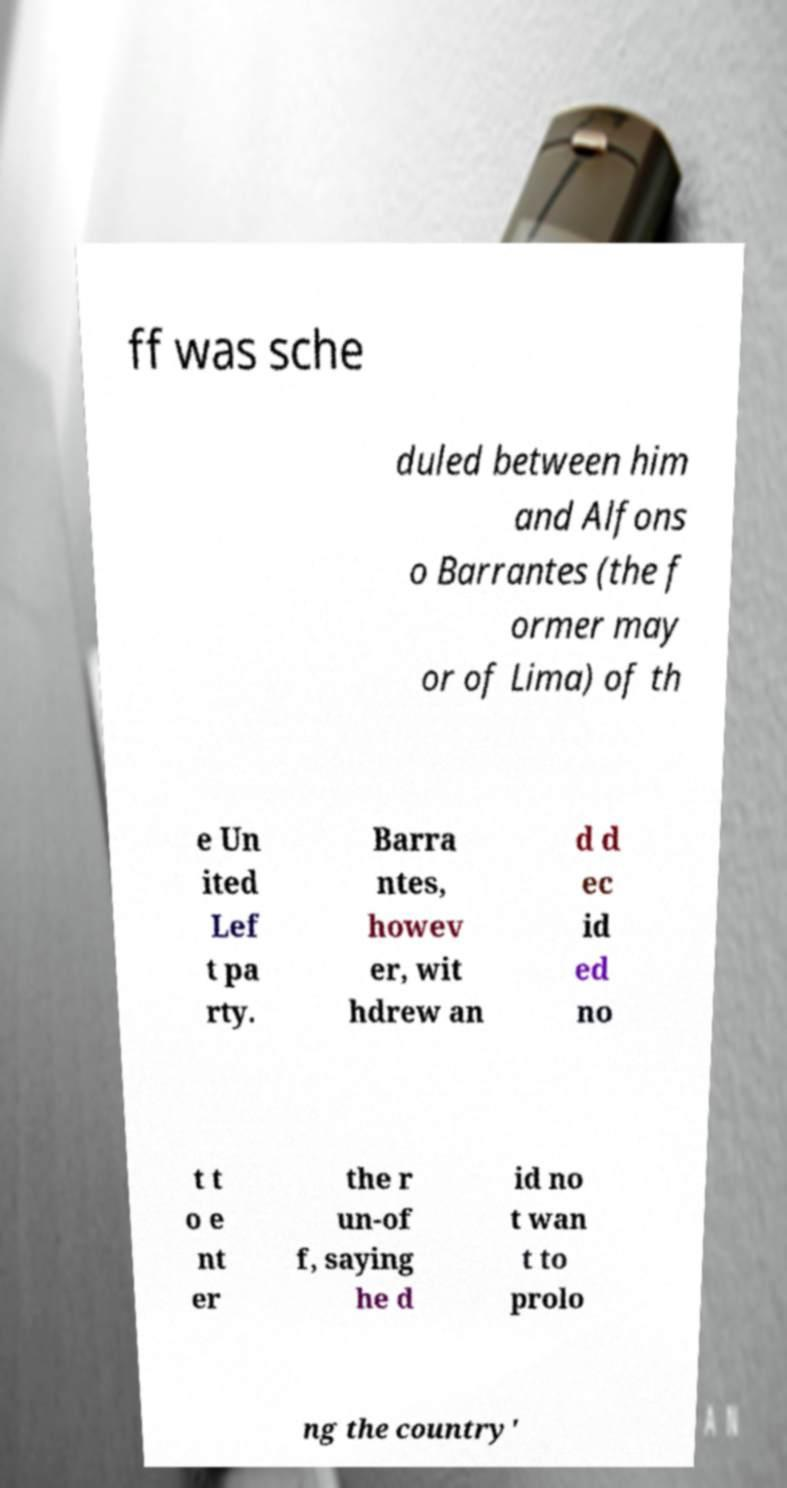Please identify and transcribe the text found in this image. ff was sche duled between him and Alfons o Barrantes (the f ormer may or of Lima) of th e Un ited Lef t pa rty. Barra ntes, howev er, wit hdrew an d d ec id ed no t t o e nt er the r un-of f, saying he d id no t wan t to prolo ng the country' 